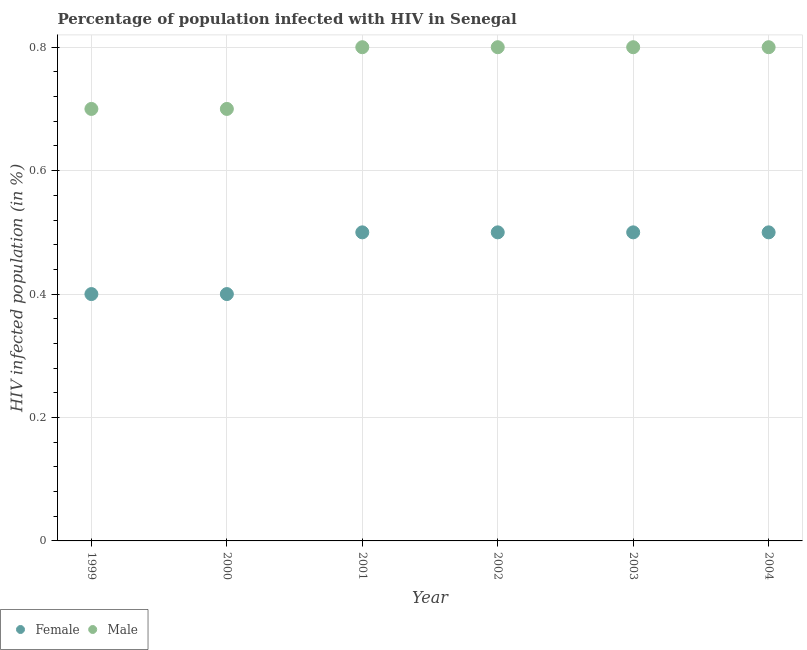Is the number of dotlines equal to the number of legend labels?
Ensure brevity in your answer.  Yes. Across all years, what is the maximum percentage of females who are infected with hiv?
Ensure brevity in your answer.  0.5. Across all years, what is the minimum percentage of males who are infected with hiv?
Your response must be concise. 0.7. In which year was the percentage of males who are infected with hiv maximum?
Your answer should be very brief. 2001. In which year was the percentage of males who are infected with hiv minimum?
Offer a very short reply. 1999. What is the total percentage of females who are infected with hiv in the graph?
Make the answer very short. 2.8. What is the difference between the percentage of females who are infected with hiv in 2002 and that in 2003?
Give a very brief answer. 0. What is the difference between the percentage of females who are infected with hiv in 2001 and the percentage of males who are infected with hiv in 1999?
Ensure brevity in your answer.  -0.2. What is the average percentage of males who are infected with hiv per year?
Give a very brief answer. 0.77. In the year 1999, what is the difference between the percentage of males who are infected with hiv and percentage of females who are infected with hiv?
Make the answer very short. 0.3. In how many years, is the percentage of females who are infected with hiv greater than 0.56 %?
Make the answer very short. 0. What is the ratio of the percentage of males who are infected with hiv in 1999 to that in 2004?
Your answer should be very brief. 0.87. What is the difference between the highest and the second highest percentage of males who are infected with hiv?
Give a very brief answer. 0. What is the difference between the highest and the lowest percentage of females who are infected with hiv?
Provide a short and direct response. 0.1. In how many years, is the percentage of males who are infected with hiv greater than the average percentage of males who are infected with hiv taken over all years?
Your answer should be compact. 4. How many years are there in the graph?
Ensure brevity in your answer.  6. Are the values on the major ticks of Y-axis written in scientific E-notation?
Ensure brevity in your answer.  No. Does the graph contain grids?
Offer a very short reply. Yes. How many legend labels are there?
Your answer should be very brief. 2. How are the legend labels stacked?
Provide a succinct answer. Horizontal. What is the title of the graph?
Provide a short and direct response. Percentage of population infected with HIV in Senegal. What is the label or title of the Y-axis?
Keep it short and to the point. HIV infected population (in %). What is the HIV infected population (in %) of Female in 1999?
Provide a succinct answer. 0.4. What is the HIV infected population (in %) in Male in 2000?
Ensure brevity in your answer.  0.7. What is the HIV infected population (in %) of Female in 2001?
Offer a terse response. 0.5. What is the HIV infected population (in %) in Male in 2001?
Your answer should be very brief. 0.8. What is the HIV infected population (in %) in Female in 2002?
Give a very brief answer. 0.5. What is the HIV infected population (in %) of Male in 2003?
Keep it short and to the point. 0.8. Across all years, what is the maximum HIV infected population (in %) in Male?
Keep it short and to the point. 0.8. Across all years, what is the minimum HIV infected population (in %) in Male?
Your answer should be very brief. 0.7. What is the difference between the HIV infected population (in %) in Male in 1999 and that in 2000?
Your response must be concise. 0. What is the difference between the HIV infected population (in %) in Female in 1999 and that in 2001?
Provide a succinct answer. -0.1. What is the difference between the HIV infected population (in %) of Male in 1999 and that in 2002?
Provide a succinct answer. -0.1. What is the difference between the HIV infected population (in %) in Female in 1999 and that in 2003?
Ensure brevity in your answer.  -0.1. What is the difference between the HIV infected population (in %) in Male in 1999 and that in 2003?
Offer a terse response. -0.1. What is the difference between the HIV infected population (in %) of Female in 1999 and that in 2004?
Give a very brief answer. -0.1. What is the difference between the HIV infected population (in %) of Male in 2000 and that in 2001?
Offer a very short reply. -0.1. What is the difference between the HIV infected population (in %) of Female in 2000 and that in 2002?
Provide a succinct answer. -0.1. What is the difference between the HIV infected population (in %) of Male in 2000 and that in 2002?
Keep it short and to the point. -0.1. What is the difference between the HIV infected population (in %) in Female in 2000 and that in 2003?
Provide a succinct answer. -0.1. What is the difference between the HIV infected population (in %) in Male in 2000 and that in 2003?
Offer a very short reply. -0.1. What is the difference between the HIV infected population (in %) of Female in 2000 and that in 2004?
Offer a very short reply. -0.1. What is the difference between the HIV infected population (in %) of Female in 2001 and that in 2002?
Provide a succinct answer. 0. What is the difference between the HIV infected population (in %) in Female in 2001 and that in 2003?
Give a very brief answer. 0. What is the difference between the HIV infected population (in %) of Female in 2001 and that in 2004?
Offer a very short reply. 0. What is the difference between the HIV infected population (in %) in Male in 2002 and that in 2003?
Provide a succinct answer. 0. What is the difference between the HIV infected population (in %) in Female in 2002 and that in 2004?
Provide a short and direct response. 0. What is the difference between the HIV infected population (in %) in Female in 2003 and that in 2004?
Ensure brevity in your answer.  0. What is the difference between the HIV infected population (in %) in Male in 2003 and that in 2004?
Give a very brief answer. 0. What is the difference between the HIV infected population (in %) in Female in 1999 and the HIV infected population (in %) in Male in 2001?
Offer a very short reply. -0.4. What is the difference between the HIV infected population (in %) in Female in 1999 and the HIV infected population (in %) in Male in 2002?
Your answer should be very brief. -0.4. What is the difference between the HIV infected population (in %) of Female in 1999 and the HIV infected population (in %) of Male in 2003?
Offer a terse response. -0.4. What is the difference between the HIV infected population (in %) of Female in 2000 and the HIV infected population (in %) of Male in 2001?
Ensure brevity in your answer.  -0.4. What is the difference between the HIV infected population (in %) of Female in 2000 and the HIV infected population (in %) of Male in 2002?
Provide a succinct answer. -0.4. What is the difference between the HIV infected population (in %) in Female in 2000 and the HIV infected population (in %) in Male in 2003?
Provide a short and direct response. -0.4. What is the difference between the HIV infected population (in %) in Female in 2000 and the HIV infected population (in %) in Male in 2004?
Provide a short and direct response. -0.4. What is the difference between the HIV infected population (in %) of Female in 2001 and the HIV infected population (in %) of Male in 2003?
Your response must be concise. -0.3. What is the difference between the HIV infected population (in %) in Female in 2001 and the HIV infected population (in %) in Male in 2004?
Make the answer very short. -0.3. What is the difference between the HIV infected population (in %) of Female in 2002 and the HIV infected population (in %) of Male in 2004?
Your answer should be very brief. -0.3. What is the difference between the HIV infected population (in %) in Female in 2003 and the HIV infected population (in %) in Male in 2004?
Give a very brief answer. -0.3. What is the average HIV infected population (in %) of Female per year?
Provide a succinct answer. 0.47. What is the average HIV infected population (in %) of Male per year?
Provide a short and direct response. 0.77. In the year 1999, what is the difference between the HIV infected population (in %) of Female and HIV infected population (in %) of Male?
Provide a short and direct response. -0.3. In the year 2000, what is the difference between the HIV infected population (in %) of Female and HIV infected population (in %) of Male?
Your answer should be very brief. -0.3. In the year 2002, what is the difference between the HIV infected population (in %) of Female and HIV infected population (in %) of Male?
Provide a short and direct response. -0.3. In the year 2003, what is the difference between the HIV infected population (in %) of Female and HIV infected population (in %) of Male?
Provide a succinct answer. -0.3. What is the ratio of the HIV infected population (in %) in Female in 1999 to that in 2001?
Your response must be concise. 0.8. What is the ratio of the HIV infected population (in %) of Male in 1999 to that in 2003?
Offer a terse response. 0.88. What is the ratio of the HIV infected population (in %) in Female in 1999 to that in 2004?
Provide a short and direct response. 0.8. What is the ratio of the HIV infected population (in %) of Female in 2000 to that in 2001?
Your response must be concise. 0.8. What is the ratio of the HIV infected population (in %) in Female in 2000 to that in 2002?
Your answer should be very brief. 0.8. What is the ratio of the HIV infected population (in %) of Male in 2000 to that in 2002?
Your answer should be compact. 0.88. What is the ratio of the HIV infected population (in %) in Female in 2000 to that in 2003?
Your answer should be very brief. 0.8. What is the ratio of the HIV infected population (in %) of Male in 2000 to that in 2003?
Give a very brief answer. 0.88. What is the ratio of the HIV infected population (in %) of Female in 2001 to that in 2002?
Your answer should be compact. 1. What is the ratio of the HIV infected population (in %) of Male in 2001 to that in 2002?
Make the answer very short. 1. What is the ratio of the HIV infected population (in %) of Female in 2001 to that in 2004?
Make the answer very short. 1. What is the ratio of the HIV infected population (in %) in Male in 2001 to that in 2004?
Offer a very short reply. 1. What is the ratio of the HIV infected population (in %) in Male in 2002 to that in 2003?
Make the answer very short. 1. What is the ratio of the HIV infected population (in %) of Female in 2002 to that in 2004?
Offer a terse response. 1. What is the ratio of the HIV infected population (in %) in Female in 2003 to that in 2004?
Give a very brief answer. 1. What is the difference between the highest and the second highest HIV infected population (in %) of Male?
Your response must be concise. 0. 